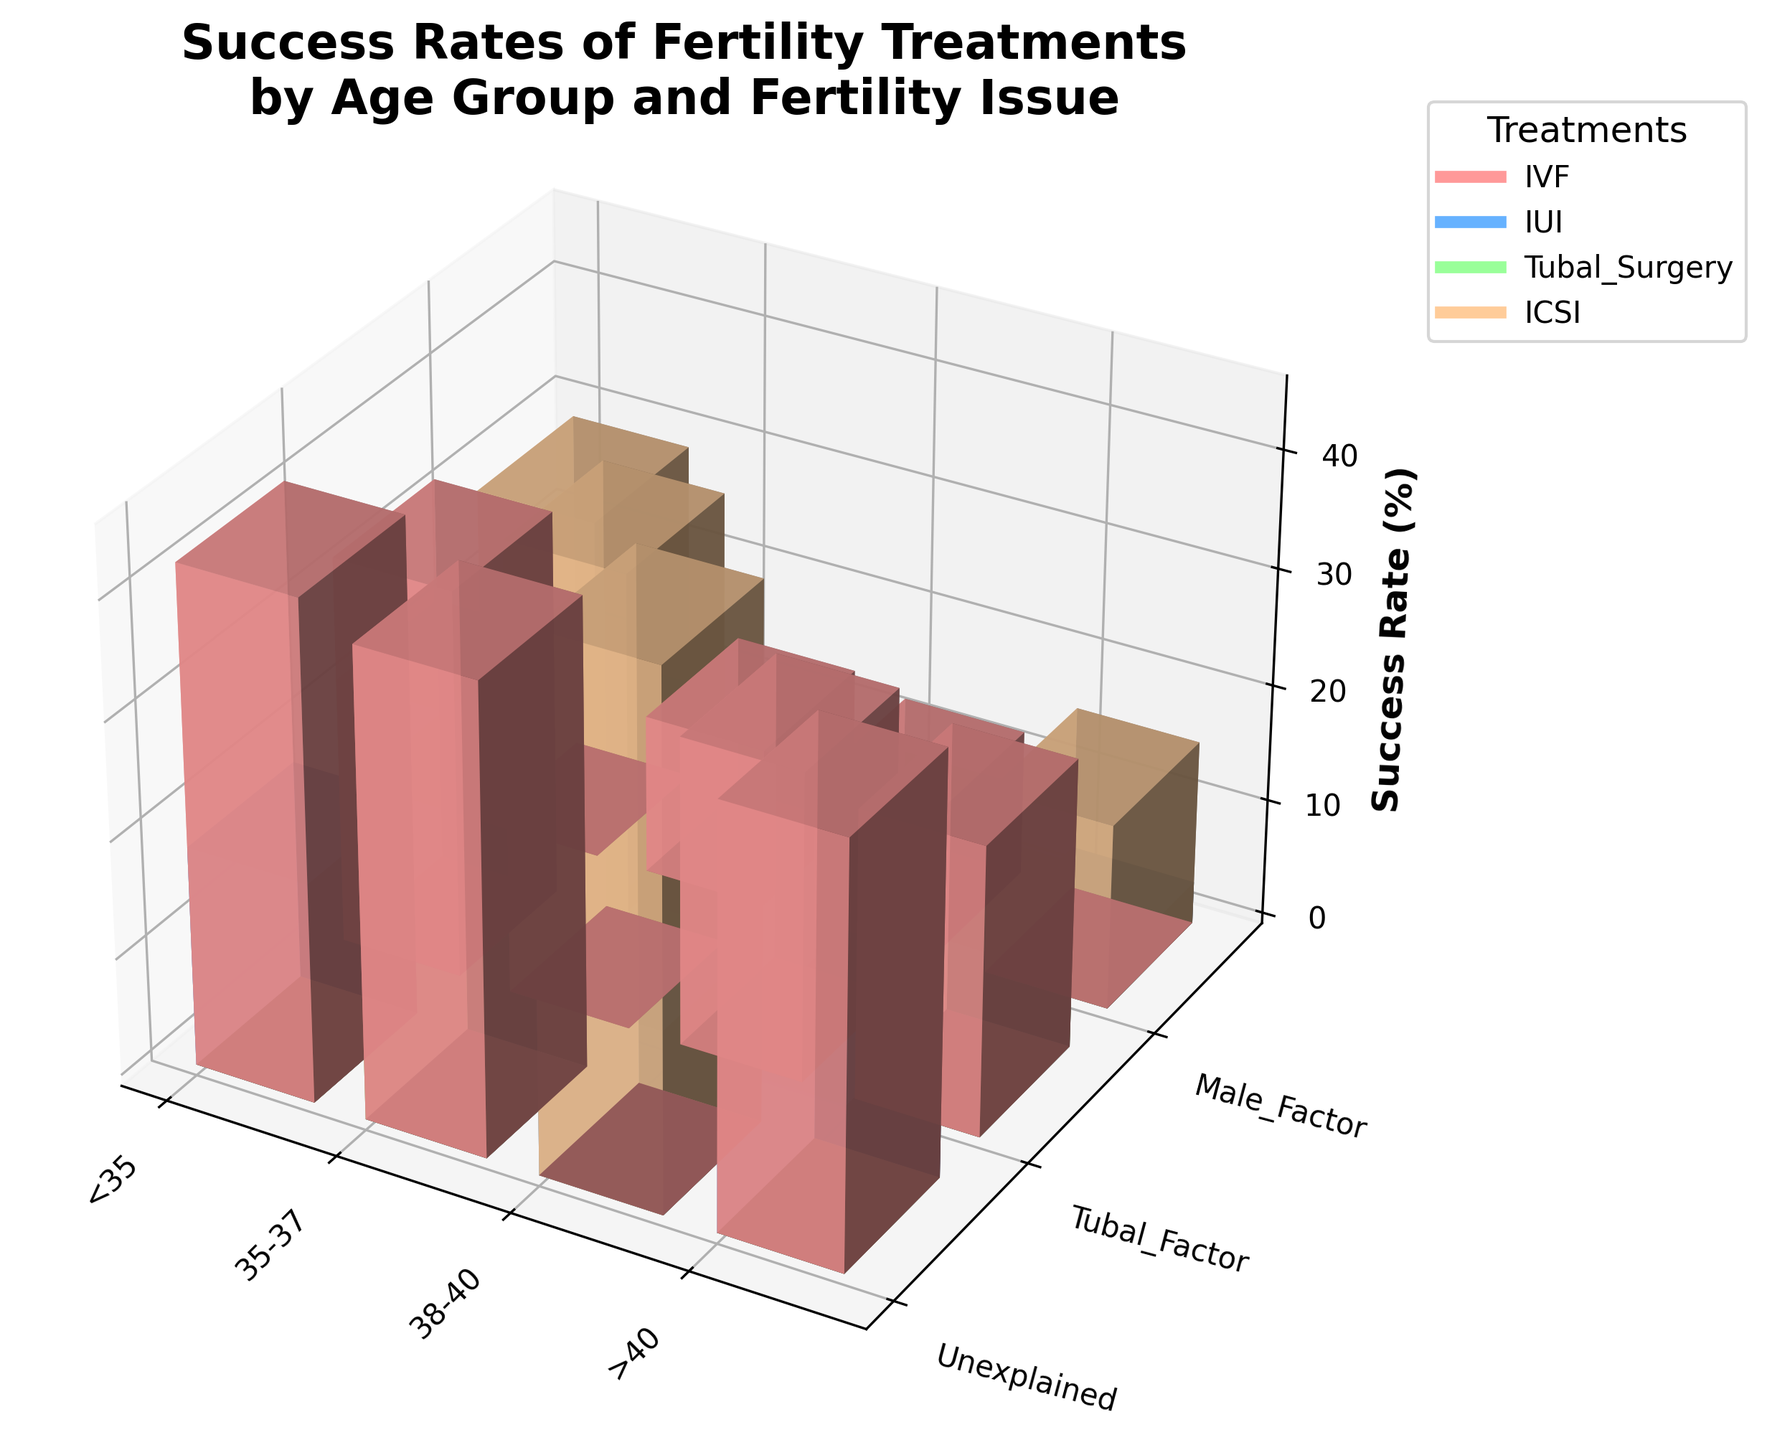What is the title of the plot? The title is located at the top of the figure. You have to look above the 3D bars to find it.
Answer: Success Rates of Fertility Treatments by Age Group and Fertility Issue What does the z-axis represent? The z-axis label should indicate what this axis stands for. It is shown vertically on the right side of the plot.
Answer: Success Rate (%) Which treatment shows the highest success rate for patients under 35 years with unexplained fertility issues? Find the bars corresponding to the age group "<35" and fertility issue "Unexplained." Among these, identify the highest bar and note the corresponding treatment from the legend.
Answer: IVF Compare the success rates of IVF for age groups <35 and 35-37 with tubal factor issues. Which age group has a higher success rate? First, locate the IVF treatment bars for the <35 and 35-37 age groups under "Tubal Factor" fertility issues. Compare the heights of these bars.
Answer: <35 Which fertility issue has the lowest success rate for IUI treatment in the age group >40? Look for the bars representing the age group ">40" and treatment "IUI." Compare the heights of the bars for each fertility issue within this subset.
Answer: Male Factor What is the range of success rates for ICSI treatment across all age groups and fertility issues? Identify all bars corresponding to ICSI treatment, observe the minimum and maximum heights, and subtract the minimum value from the maximum value. More specifically, ICSI bars range from the highest to the lowest success rate based on the data provided.
Answer: 45.2 - 15.9 = 29.3% Which age group and treatment combination has the highest overall success rate? Find the highest overall bar in the 3D plot and note the corresponding age group, fertility issue, and treatment. Cross-reference with the legend if necessary.
Answer: <35, Male Factor, ICSI How do success rates for IVF compare between unexplained infertility and male factor infertility for the 38-40 age group? Locate the IVF bars for the age group 38-40. Compare the height of the "Unexplained" bar with the "Male Factor" bar.
Answer: Unexplained: 26.4%, Male Factor: 29.3%. Male Factor is higher What pattern do you observe in success rates for IUI across different age groups? Examine the height of IUI bars across all age groups and fertility issues. Identify any trend as age increases.
Answer: Success rate consistently decreases as age increases 